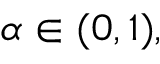<formula> <loc_0><loc_0><loc_500><loc_500>\alpha \in ( 0 , 1 ) ,</formula> 